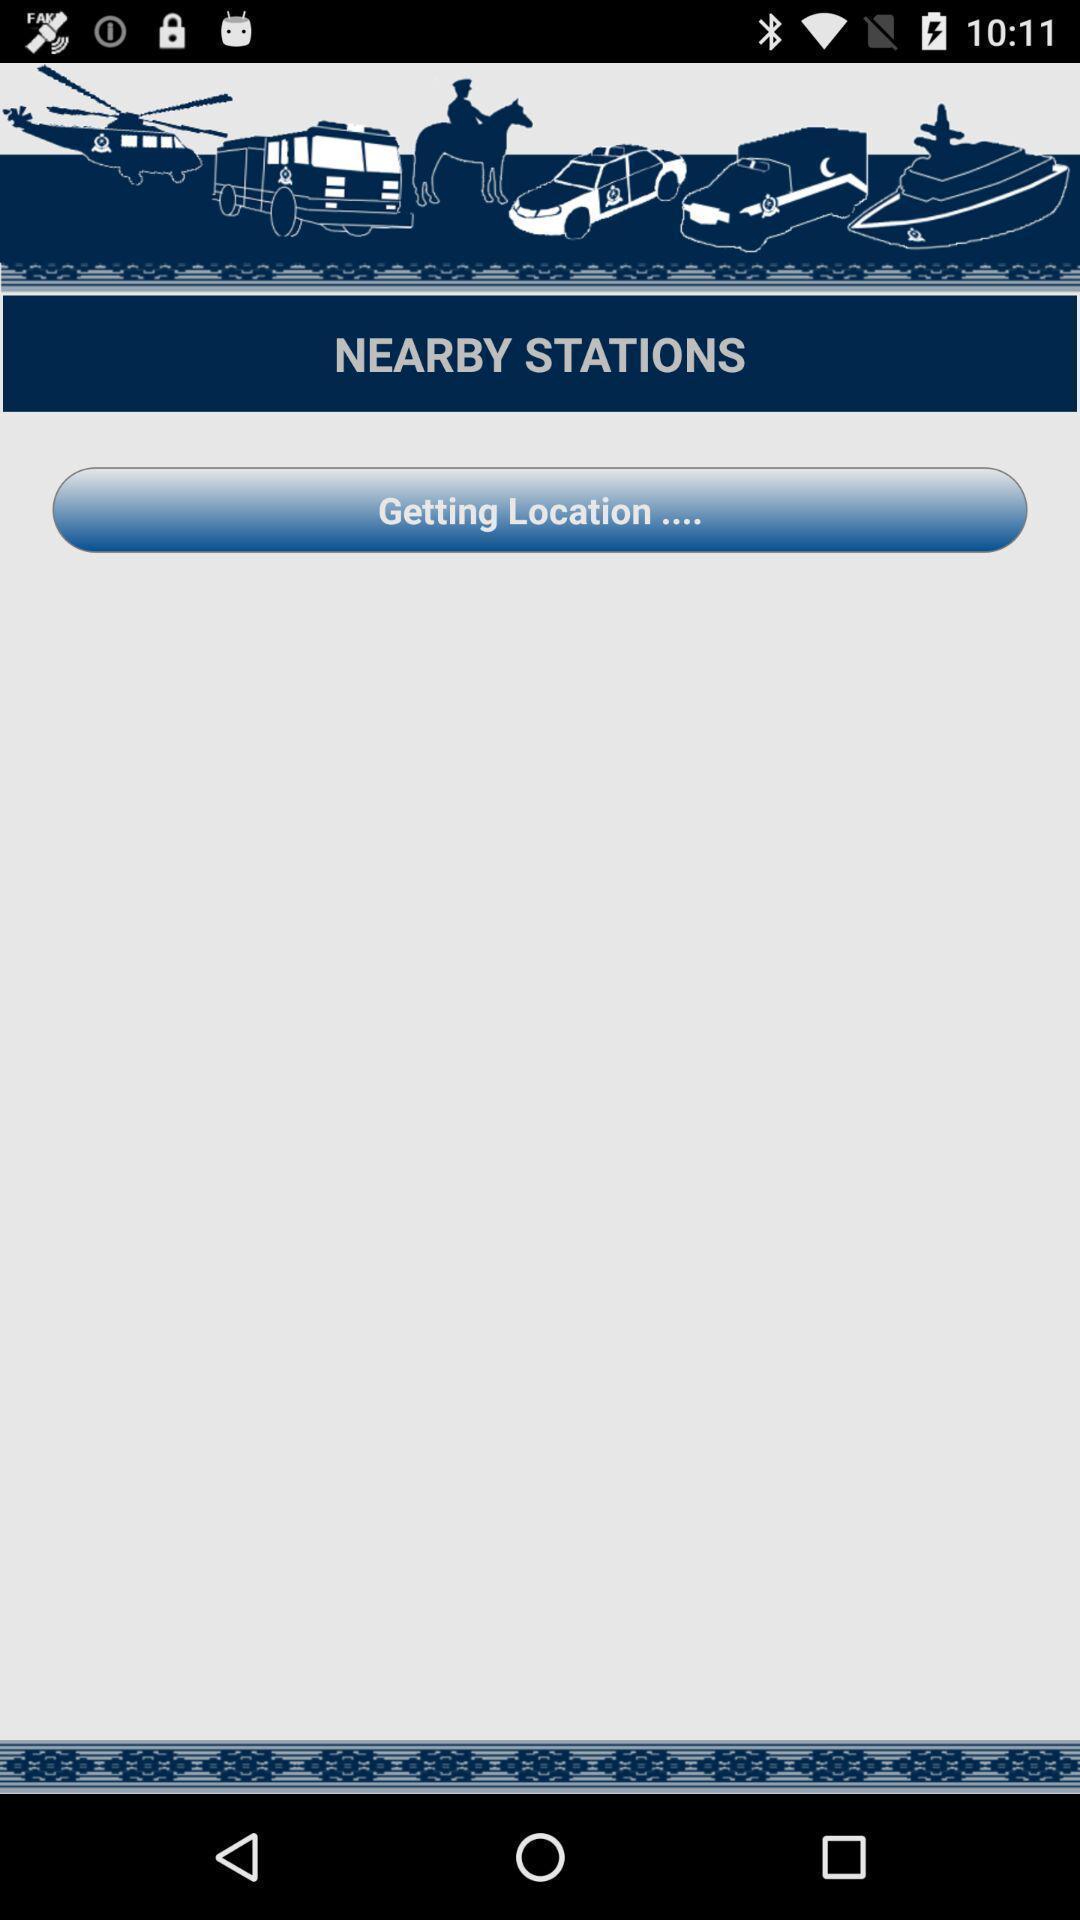Please provide a description for this image. Screen shows multiple options. 